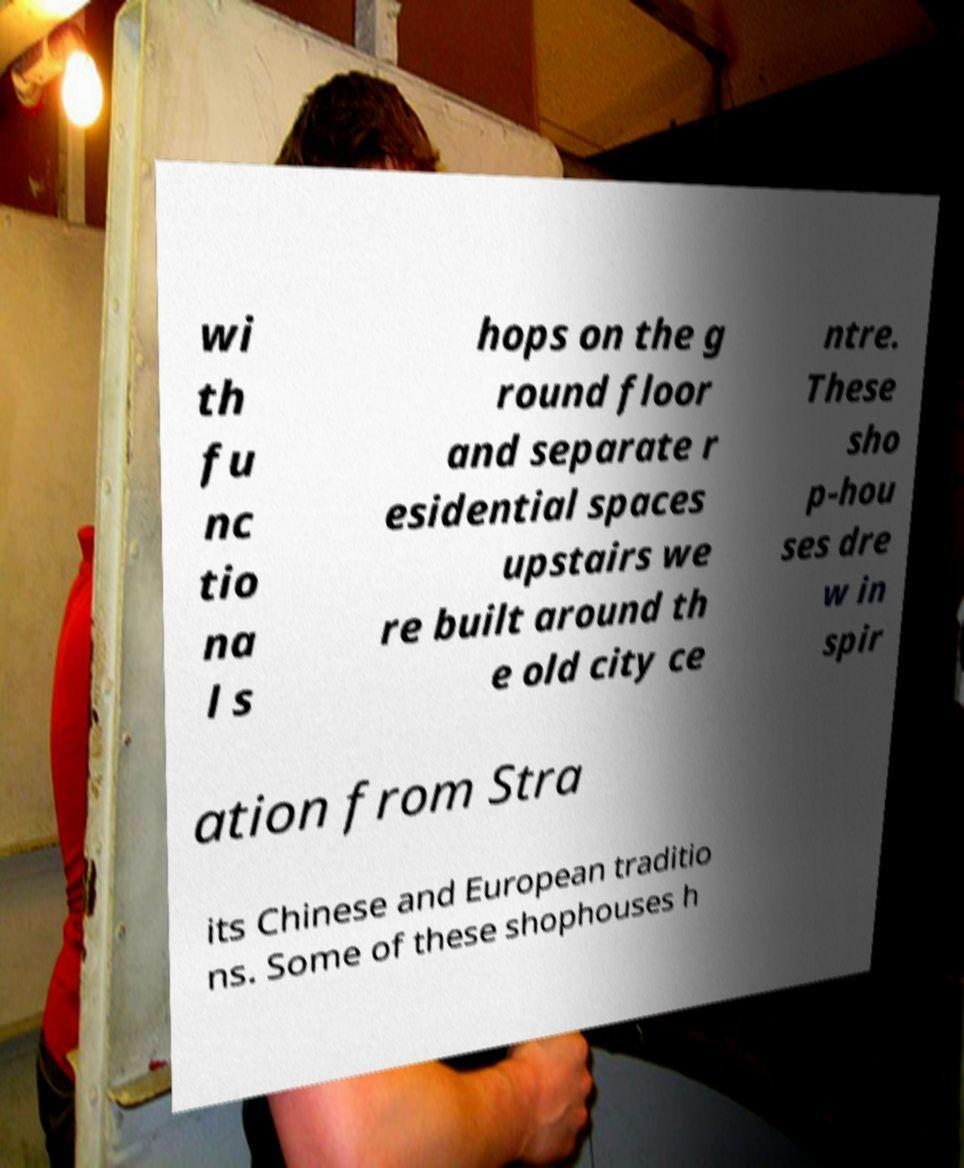Please identify and transcribe the text found in this image. wi th fu nc tio na l s hops on the g round floor and separate r esidential spaces upstairs we re built around th e old city ce ntre. These sho p-hou ses dre w in spir ation from Stra its Chinese and European traditio ns. Some of these shophouses h 